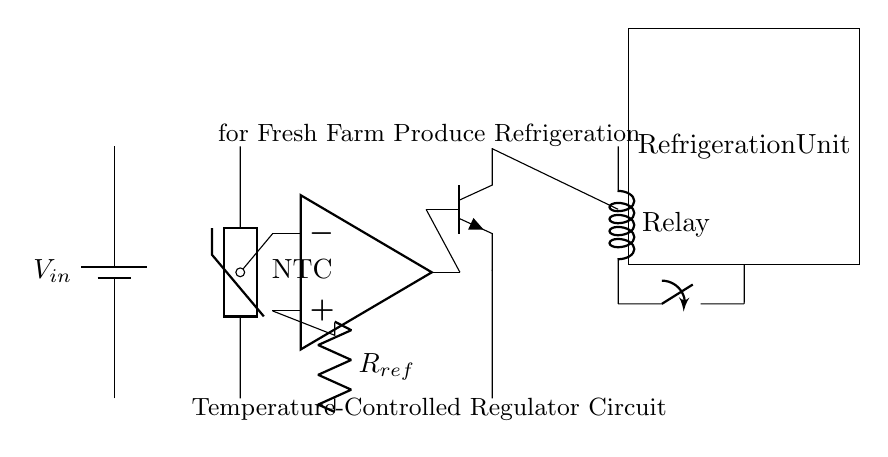What is the main function of this circuit? The main function is to regulate the temperature for refrigeration of fresh farm produce. The circuit maintains a controlled environment by automatically turning the refrigeration unit on or off based on the temperature detected by the thermistor.
Answer: temperature regulation What type of temperature sensor is used in this circuit? The circuit employs a thermistor, specifically a Negative Temperature Coefficient (NTC) thermistor, which decreases resistance with increasing temperature. This allows the sensor to provide temperature readings that can be compared to a reference voltage.
Answer: NTC thermistor How is the comparator connected in this circuit? The comparator is configured using an operational amplifier, where one input is connected to the thermistor output, and the other input is connected to a reference resistor. This configuration allows the comparator to compare the actual temperature against a preset reference.
Answer: Through an op-amp What component controls the refrigeration unit? The refrigeration unit is controlled by a relay, which is actuated by a transistor that receives its input from the comparator's output. When conditions are met, the relay switches the refrigeration unit on or off.
Answer: Relay What happens when the temperature exceeds the reference level? When the temperature exceeds the reference level, the output of the comparator goes high, activating the transistor. This allows current to flow through the relay, which subsequently turns on the refrigeration unit to lower the temperature.
Answer: The refrigeration unit turns on What role does the reference resistor play in this circuit? The reference resistor sets a threshold voltage for the comparator. By determining the reference level against which the thermistor's voltage is measured, it plays a crucial role in defining when the refrigeration unit should be activated or deactivated.
Answer: Defines threshold voltage 